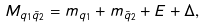<formula> <loc_0><loc_0><loc_500><loc_500>M _ { q _ { 1 } \bar { q } _ { 2 } } = m _ { q _ { 1 } } + m _ { \bar { q } _ { 2 } } + E + \Delta ,</formula> 